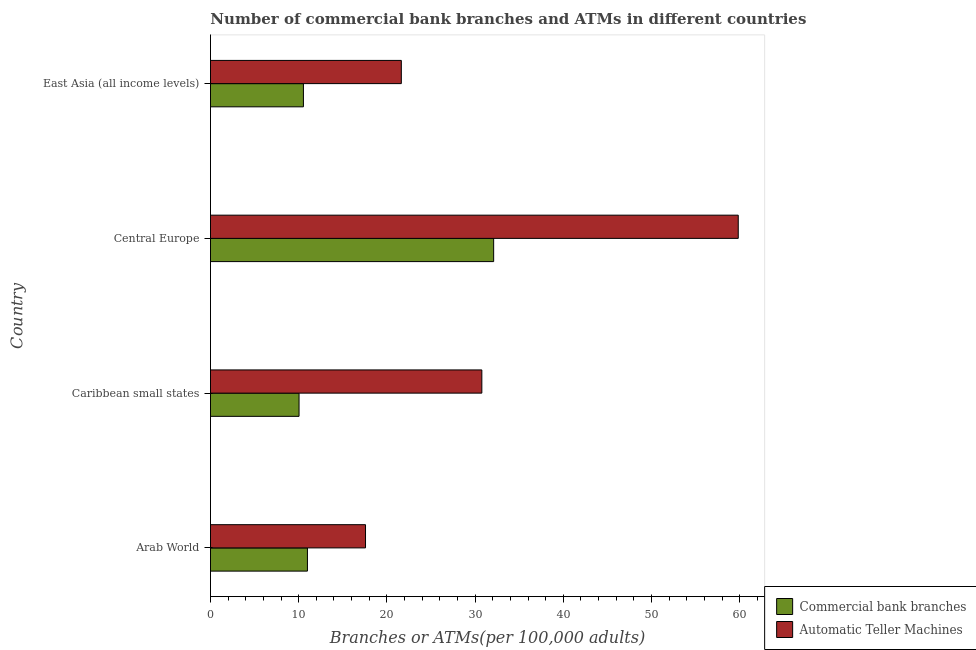Are the number of bars on each tick of the Y-axis equal?
Your answer should be very brief. Yes. What is the label of the 3rd group of bars from the top?
Ensure brevity in your answer.  Caribbean small states. What is the number of commercal bank branches in Central Europe?
Make the answer very short. 32.11. Across all countries, what is the maximum number of commercal bank branches?
Offer a terse response. 32.11. Across all countries, what is the minimum number of atms?
Provide a succinct answer. 17.58. In which country was the number of commercal bank branches maximum?
Offer a terse response. Central Europe. In which country was the number of commercal bank branches minimum?
Your response must be concise. Caribbean small states. What is the total number of commercal bank branches in the graph?
Offer a terse response. 63.68. What is the difference between the number of atms in Arab World and that in Central Europe?
Your answer should be very brief. -42.26. What is the difference between the number of atms in Caribbean small states and the number of commercal bank branches in Arab World?
Your answer should be compact. 19.77. What is the average number of commercal bank branches per country?
Give a very brief answer. 15.92. What is the difference between the number of atms and number of commercal bank branches in Caribbean small states?
Provide a succinct answer. 20.72. What is the ratio of the number of commercal bank branches in Caribbean small states to that in East Asia (all income levels)?
Provide a short and direct response. 0.95. Is the number of commercal bank branches in Caribbean small states less than that in Central Europe?
Make the answer very short. Yes. Is the difference between the number of commercal bank branches in Caribbean small states and East Asia (all income levels) greater than the difference between the number of atms in Caribbean small states and East Asia (all income levels)?
Give a very brief answer. No. What is the difference between the highest and the second highest number of commercal bank branches?
Keep it short and to the point. 21.11. What is the difference between the highest and the lowest number of atms?
Provide a succinct answer. 42.26. In how many countries, is the number of atms greater than the average number of atms taken over all countries?
Your response must be concise. 1. What does the 2nd bar from the top in Central Europe represents?
Offer a terse response. Commercial bank branches. What does the 2nd bar from the bottom in East Asia (all income levels) represents?
Provide a short and direct response. Automatic Teller Machines. Are all the bars in the graph horizontal?
Offer a very short reply. Yes. What is the difference between two consecutive major ticks on the X-axis?
Your answer should be very brief. 10. What is the title of the graph?
Your response must be concise. Number of commercial bank branches and ATMs in different countries. What is the label or title of the X-axis?
Make the answer very short. Branches or ATMs(per 100,0 adults). What is the label or title of the Y-axis?
Ensure brevity in your answer.  Country. What is the Branches or ATMs(per 100,000 adults) in Commercial bank branches in Arab World?
Offer a very short reply. 10.99. What is the Branches or ATMs(per 100,000 adults) in Automatic Teller Machines in Arab World?
Make the answer very short. 17.58. What is the Branches or ATMs(per 100,000 adults) of Commercial bank branches in Caribbean small states?
Give a very brief answer. 10.04. What is the Branches or ATMs(per 100,000 adults) of Automatic Teller Machines in Caribbean small states?
Offer a very short reply. 30.77. What is the Branches or ATMs(per 100,000 adults) in Commercial bank branches in Central Europe?
Your answer should be very brief. 32.11. What is the Branches or ATMs(per 100,000 adults) in Automatic Teller Machines in Central Europe?
Make the answer very short. 59.84. What is the Branches or ATMs(per 100,000 adults) in Commercial bank branches in East Asia (all income levels)?
Provide a short and direct response. 10.54. What is the Branches or ATMs(per 100,000 adults) of Automatic Teller Machines in East Asia (all income levels)?
Your answer should be compact. 21.64. Across all countries, what is the maximum Branches or ATMs(per 100,000 adults) in Commercial bank branches?
Provide a short and direct response. 32.11. Across all countries, what is the maximum Branches or ATMs(per 100,000 adults) in Automatic Teller Machines?
Offer a terse response. 59.84. Across all countries, what is the minimum Branches or ATMs(per 100,000 adults) in Commercial bank branches?
Your answer should be compact. 10.04. Across all countries, what is the minimum Branches or ATMs(per 100,000 adults) of Automatic Teller Machines?
Your answer should be very brief. 17.58. What is the total Branches or ATMs(per 100,000 adults) of Commercial bank branches in the graph?
Offer a terse response. 63.68. What is the total Branches or ATMs(per 100,000 adults) in Automatic Teller Machines in the graph?
Your answer should be compact. 129.82. What is the difference between the Branches or ATMs(per 100,000 adults) in Commercial bank branches in Arab World and that in Caribbean small states?
Keep it short and to the point. 0.95. What is the difference between the Branches or ATMs(per 100,000 adults) in Automatic Teller Machines in Arab World and that in Caribbean small states?
Offer a terse response. -13.19. What is the difference between the Branches or ATMs(per 100,000 adults) of Commercial bank branches in Arab World and that in Central Europe?
Offer a very short reply. -21.11. What is the difference between the Branches or ATMs(per 100,000 adults) of Automatic Teller Machines in Arab World and that in Central Europe?
Provide a short and direct response. -42.26. What is the difference between the Branches or ATMs(per 100,000 adults) in Commercial bank branches in Arab World and that in East Asia (all income levels)?
Offer a terse response. 0.46. What is the difference between the Branches or ATMs(per 100,000 adults) of Automatic Teller Machines in Arab World and that in East Asia (all income levels)?
Provide a short and direct response. -4.06. What is the difference between the Branches or ATMs(per 100,000 adults) of Commercial bank branches in Caribbean small states and that in Central Europe?
Make the answer very short. -22.06. What is the difference between the Branches or ATMs(per 100,000 adults) in Automatic Teller Machines in Caribbean small states and that in Central Europe?
Provide a short and direct response. -29.07. What is the difference between the Branches or ATMs(per 100,000 adults) in Commercial bank branches in Caribbean small states and that in East Asia (all income levels)?
Your response must be concise. -0.49. What is the difference between the Branches or ATMs(per 100,000 adults) of Automatic Teller Machines in Caribbean small states and that in East Asia (all income levels)?
Give a very brief answer. 9.13. What is the difference between the Branches or ATMs(per 100,000 adults) of Commercial bank branches in Central Europe and that in East Asia (all income levels)?
Offer a very short reply. 21.57. What is the difference between the Branches or ATMs(per 100,000 adults) in Automatic Teller Machines in Central Europe and that in East Asia (all income levels)?
Provide a succinct answer. 38.2. What is the difference between the Branches or ATMs(per 100,000 adults) in Commercial bank branches in Arab World and the Branches or ATMs(per 100,000 adults) in Automatic Teller Machines in Caribbean small states?
Ensure brevity in your answer.  -19.77. What is the difference between the Branches or ATMs(per 100,000 adults) in Commercial bank branches in Arab World and the Branches or ATMs(per 100,000 adults) in Automatic Teller Machines in Central Europe?
Keep it short and to the point. -48.84. What is the difference between the Branches or ATMs(per 100,000 adults) of Commercial bank branches in Arab World and the Branches or ATMs(per 100,000 adults) of Automatic Teller Machines in East Asia (all income levels)?
Keep it short and to the point. -10.65. What is the difference between the Branches or ATMs(per 100,000 adults) in Commercial bank branches in Caribbean small states and the Branches or ATMs(per 100,000 adults) in Automatic Teller Machines in Central Europe?
Offer a very short reply. -49.79. What is the difference between the Branches or ATMs(per 100,000 adults) in Commercial bank branches in Caribbean small states and the Branches or ATMs(per 100,000 adults) in Automatic Teller Machines in East Asia (all income levels)?
Give a very brief answer. -11.6. What is the difference between the Branches or ATMs(per 100,000 adults) in Commercial bank branches in Central Europe and the Branches or ATMs(per 100,000 adults) in Automatic Teller Machines in East Asia (all income levels)?
Provide a short and direct response. 10.47. What is the average Branches or ATMs(per 100,000 adults) in Commercial bank branches per country?
Your answer should be compact. 15.92. What is the average Branches or ATMs(per 100,000 adults) of Automatic Teller Machines per country?
Ensure brevity in your answer.  32.46. What is the difference between the Branches or ATMs(per 100,000 adults) in Commercial bank branches and Branches or ATMs(per 100,000 adults) in Automatic Teller Machines in Arab World?
Offer a terse response. -6.59. What is the difference between the Branches or ATMs(per 100,000 adults) in Commercial bank branches and Branches or ATMs(per 100,000 adults) in Automatic Teller Machines in Caribbean small states?
Keep it short and to the point. -20.72. What is the difference between the Branches or ATMs(per 100,000 adults) in Commercial bank branches and Branches or ATMs(per 100,000 adults) in Automatic Teller Machines in Central Europe?
Keep it short and to the point. -27.73. What is the difference between the Branches or ATMs(per 100,000 adults) of Commercial bank branches and Branches or ATMs(per 100,000 adults) of Automatic Teller Machines in East Asia (all income levels)?
Provide a succinct answer. -11.1. What is the ratio of the Branches or ATMs(per 100,000 adults) of Commercial bank branches in Arab World to that in Caribbean small states?
Provide a short and direct response. 1.09. What is the ratio of the Branches or ATMs(per 100,000 adults) in Commercial bank branches in Arab World to that in Central Europe?
Offer a terse response. 0.34. What is the ratio of the Branches or ATMs(per 100,000 adults) in Automatic Teller Machines in Arab World to that in Central Europe?
Your response must be concise. 0.29. What is the ratio of the Branches or ATMs(per 100,000 adults) in Commercial bank branches in Arab World to that in East Asia (all income levels)?
Make the answer very short. 1.04. What is the ratio of the Branches or ATMs(per 100,000 adults) in Automatic Teller Machines in Arab World to that in East Asia (all income levels)?
Provide a succinct answer. 0.81. What is the ratio of the Branches or ATMs(per 100,000 adults) of Commercial bank branches in Caribbean small states to that in Central Europe?
Provide a succinct answer. 0.31. What is the ratio of the Branches or ATMs(per 100,000 adults) in Automatic Teller Machines in Caribbean small states to that in Central Europe?
Your response must be concise. 0.51. What is the ratio of the Branches or ATMs(per 100,000 adults) of Commercial bank branches in Caribbean small states to that in East Asia (all income levels)?
Offer a terse response. 0.95. What is the ratio of the Branches or ATMs(per 100,000 adults) in Automatic Teller Machines in Caribbean small states to that in East Asia (all income levels)?
Provide a short and direct response. 1.42. What is the ratio of the Branches or ATMs(per 100,000 adults) of Commercial bank branches in Central Europe to that in East Asia (all income levels)?
Offer a terse response. 3.05. What is the ratio of the Branches or ATMs(per 100,000 adults) of Automatic Teller Machines in Central Europe to that in East Asia (all income levels)?
Offer a very short reply. 2.77. What is the difference between the highest and the second highest Branches or ATMs(per 100,000 adults) of Commercial bank branches?
Offer a very short reply. 21.11. What is the difference between the highest and the second highest Branches or ATMs(per 100,000 adults) in Automatic Teller Machines?
Offer a terse response. 29.07. What is the difference between the highest and the lowest Branches or ATMs(per 100,000 adults) of Commercial bank branches?
Keep it short and to the point. 22.06. What is the difference between the highest and the lowest Branches or ATMs(per 100,000 adults) in Automatic Teller Machines?
Make the answer very short. 42.26. 